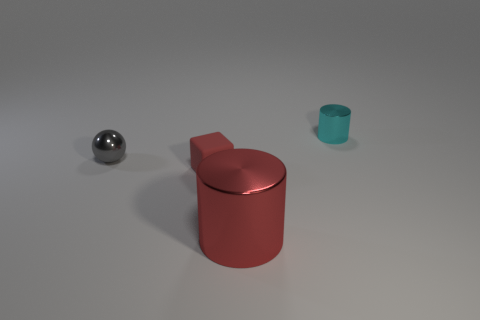What is the feeling conveyed by the composition and lighting of the scene? The scene has a neutral tone with soft lighting, creating a calm and serene atmosphere. It gives the impression of a controlled setting, designed to focus attention on the objects without distraction. 